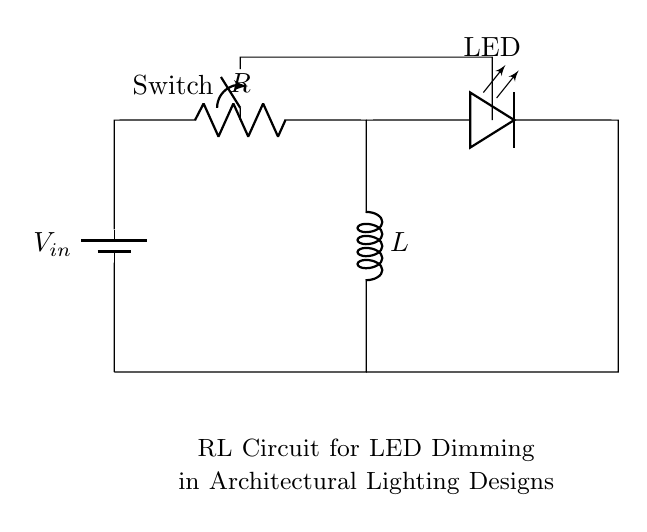What is the resistance value in the circuit? The resistance value is labeled 'R' in the diagram, indicating that it is a key component in the circuit used to control the current.
Answer: R What type of switch is used in the circuit? The switch shown in the diagram is a single-pole single-throw (SPST) switch, indicated by its specific symbol, allowing for a simple on/off control for the circuit.
Answer: SPST How many inductors are present in the circuit? The circuit has one inductor, as indicated by the 'L' symbol next to it, showing there is a single inductor used for current regulation.
Answer: 1 What does the LED represent in the circuit? The LED in this circuit represents a light-emitting diode, which turns on when sufficient current flows through it, providing illumination in the architectural design.
Answer: Light-emitting diode What happens to the LED's brightness when the resistance increases? Increasing the resistance reduces the current flowing through the circuit, thus decreasing the brightness of the LED as it leads to less power being delivered to the LED.
Answer: Decreases What is the purpose of the inductor in this circuit? The inductor is used to smooth out fluctuations in current, providing a more stable current flow to the LED for consistent lighting in architectural applications.
Answer: Smoothing current If the switch is open, what can be said about the current in the circuit? When the switch is open, it creates a break in the circuit, preventing any current from flowing through, which means the LED will not light up.
Answer: No current flows 